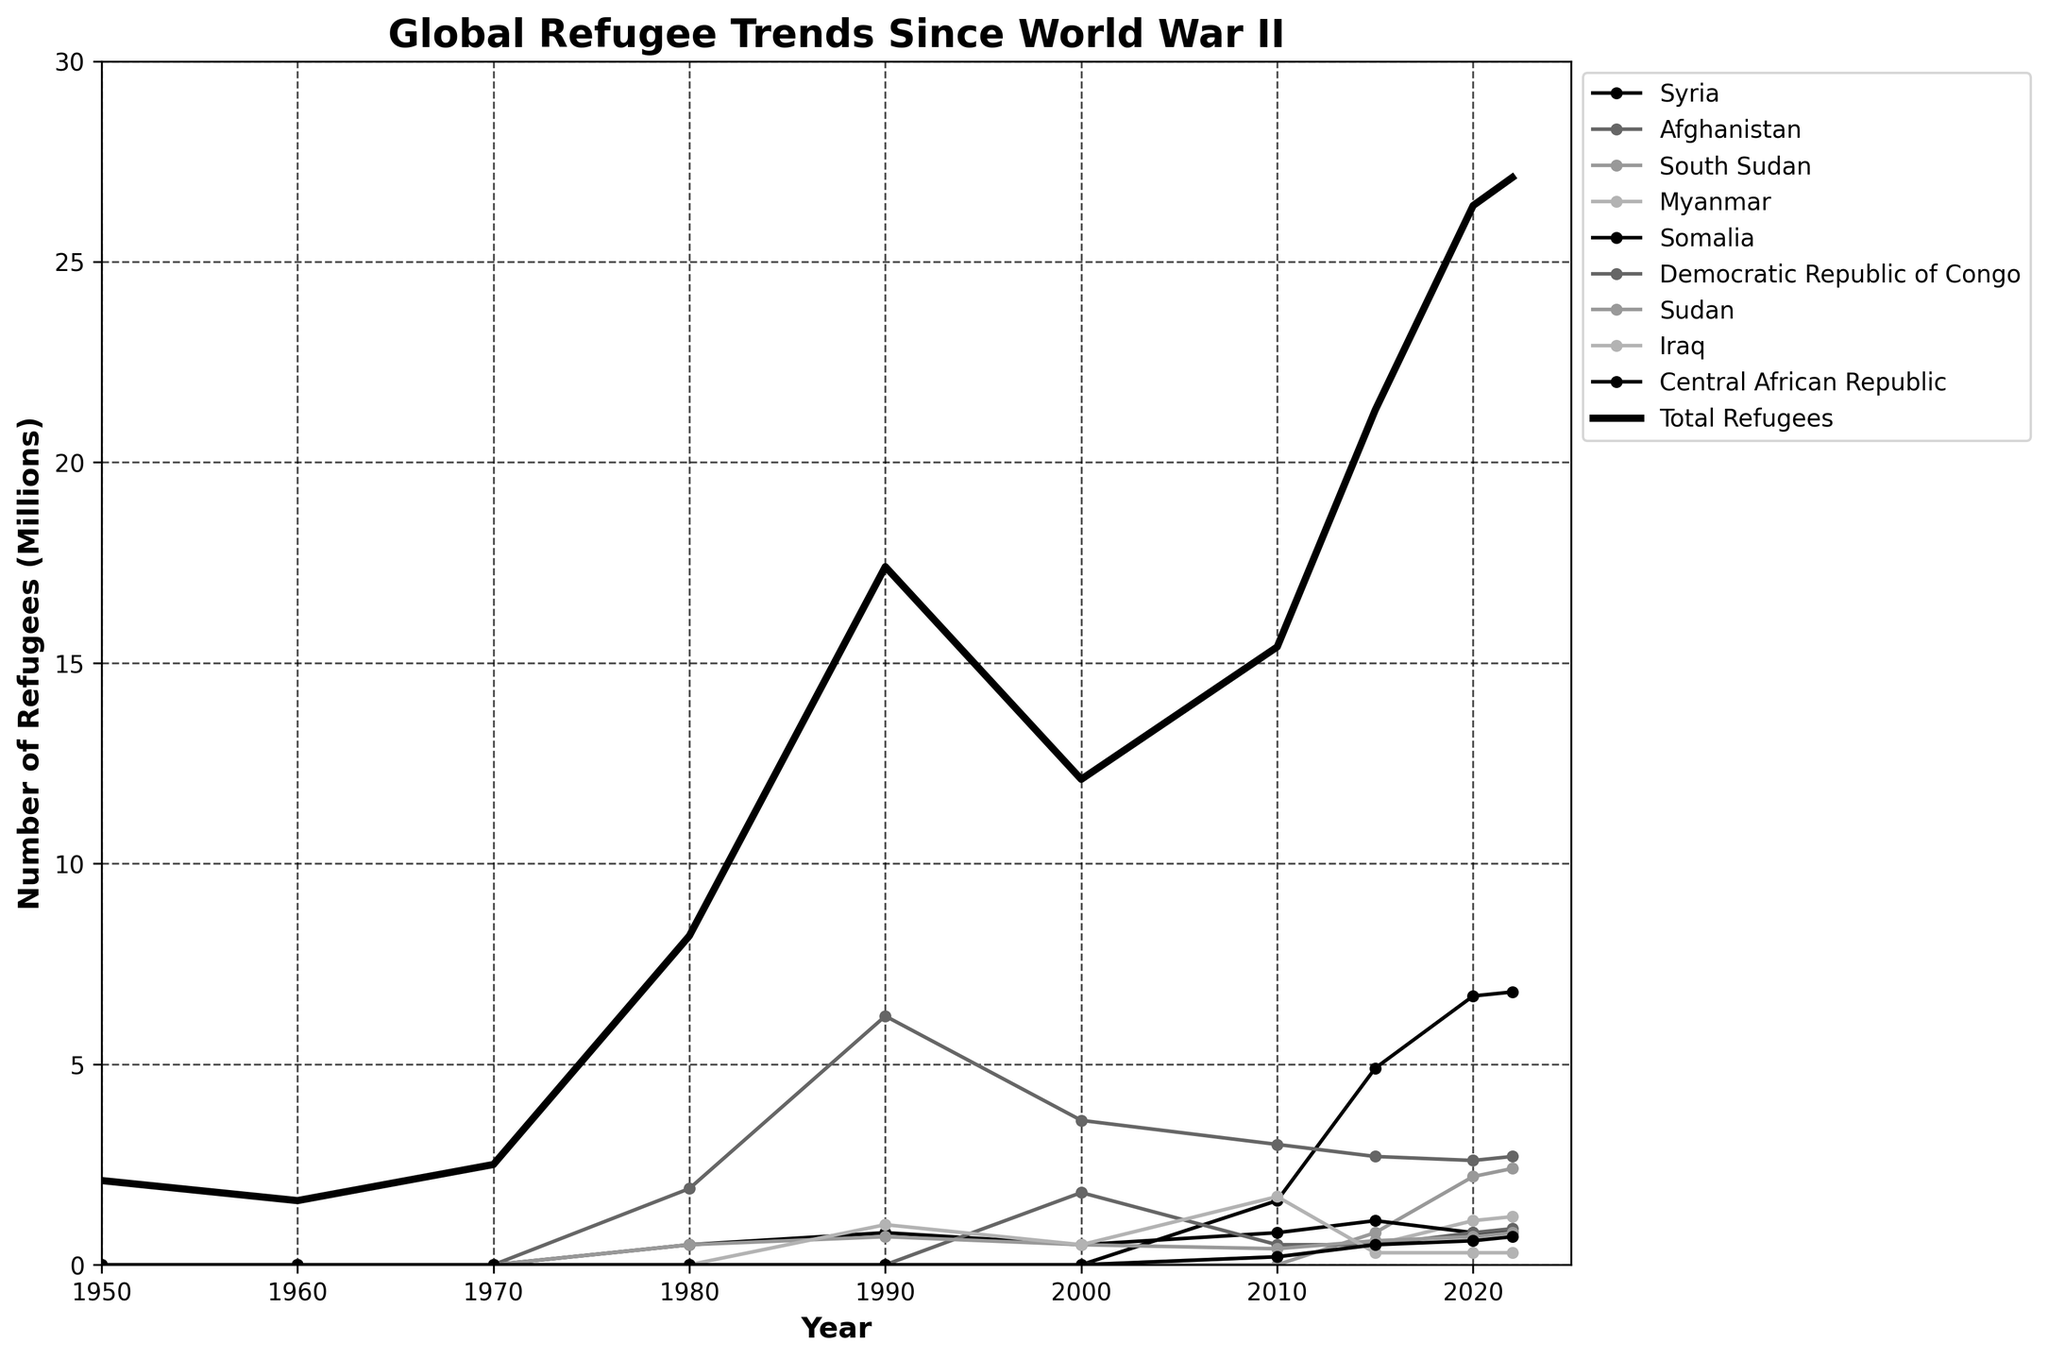What's the trend in the total number of refugees between 1950 and 2022? To observe the trend, look at the line representing "Total Refugees" spanning from 1950 to 2022. The line shows an increase from 2.1 million in 1950 to 27.1 million by 2022, indicating a long-term upward trend.
Answer: Increasing Which country had the largest refugee population in 2020? Examine the individual lines for each country and compare their y-values in 2020. The line representing Syria reaches 6.7 million in 2020, the highest among all countries.
Answer: Syria How does the refugee population from Afghanistan in 1980 compare to 2000? Check the y-values on the Afghanistan line for the years 1980 and 2000. In 1980, Afghanistan had 1.9 million refugees, while in 2000, it had 3.6 million. The population nearly doubled.
Answer: Almost doubled What was the combined total refugee population for Somalia and South Sudan in 2022? Look for the y-values of Somalia and South Sudan in 2022. Somalia has 0.8 million, and South Sudan has 2.4 million. Adding these gives 0.8 + 2.4 = 3.2 million.
Answer: 3.2 million In which decade did the global refugee population experience the highest increase? Compare the changes in the "Total Refugees" line from decade to decade. The largest increase happens between 1970 (2.5 million) and 1980 (8.2 million), showing a rise of 5.7 million.
Answer: 1970s Between Syria and Iraq, which country saw a larger growth in refugee population between 2010 and 2015? Look at the changes in y-values for Syria and Iraq between 2010 and 2015. Syria increased from 1.6 million to 4.9 million (3.3 million growth), while Iraq went from 1.7 million to 0.3 million (a decrease). Syria saw a larger growth.
Answer: Syria How does the refugee population from Myanmar in 2020 compare to 2015? Check the y-values for Myanmar in 2015 and 2020. In 2015, Myanmar had 0.5 million refugees, and in 2020, it had 1.1 million, indicating a 0.6 million increase.
Answer: Increased by 0.6 million Which country's refugee line shows a sudden rise around 2015? Identify the line with a steep increase around the year 2015. The line for Syria shows a significant rise from approximately 1.6 million in 2010 to 4.9 million in 2015.
Answer: Syria What is the average number of refugees originating from Sudan from 1980 to 2022? Sum the refugee numbers from Sudan for 1980 (0.5 million), 1990 (0.7 million), 2000 (0.5 million), 2010 (0.4 million), 2015 (0.6 million), 2020 (0.7 million), and 2022 (0.8 million). Then divide by 7. (0.5+0.7+0.5+0.4+0.6+0.7+0.8)/7 ≈ 0.6 million.
Answer: 0.6 million What visual feature distinguishes the "Total Refugees" line from the other country lines in the chart? The "Total Refugees" line is characterized by a black color and a thicker (3 pixels) line width compared to the other lines, which are thinner and colored differently.
Answer: Black and thicker 